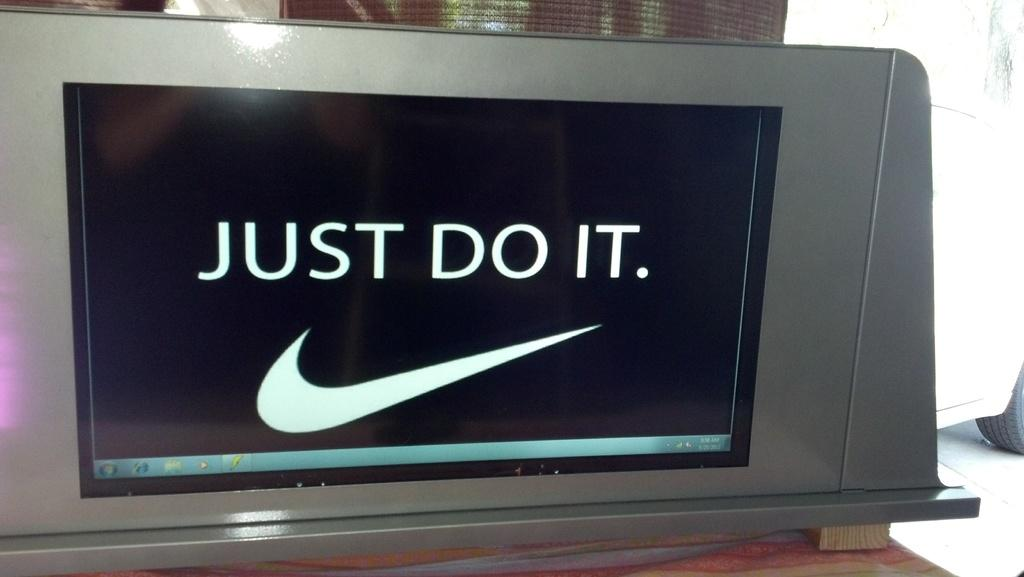Provide a one-sentence caption for the provided image. An advertising sign with the Nike swoosh symbol and the words Just Do It. 